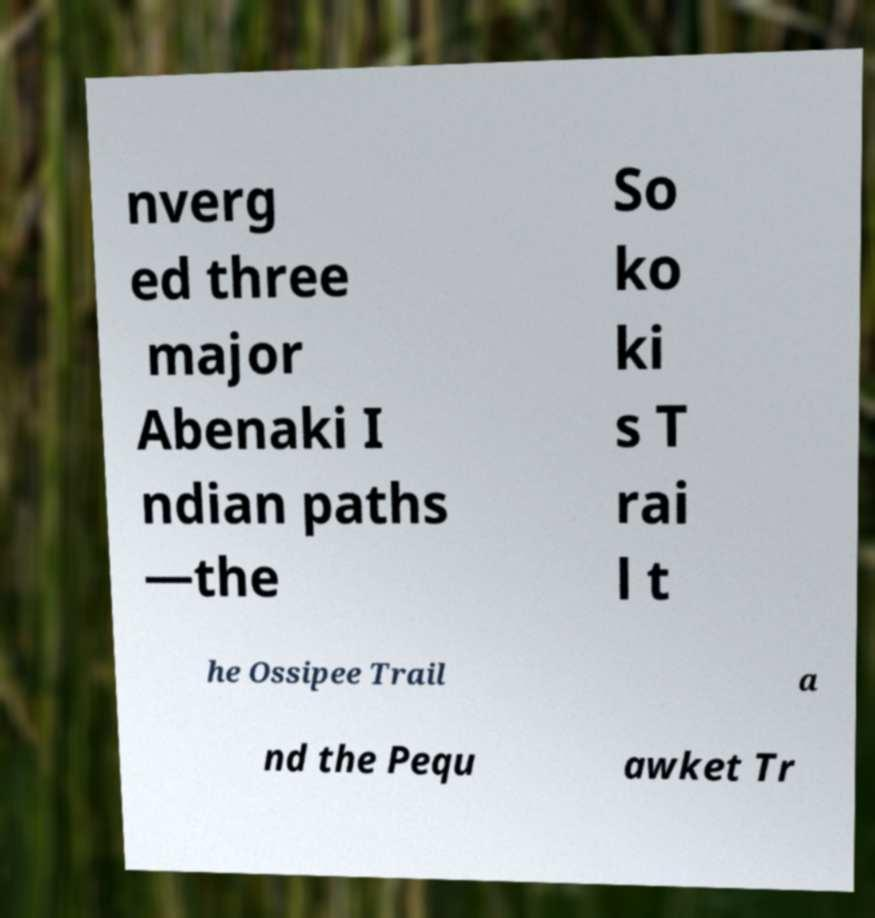There's text embedded in this image that I need extracted. Can you transcribe it verbatim? nverg ed three major Abenaki I ndian paths —the So ko ki s T rai l t he Ossipee Trail a nd the Pequ awket Tr 